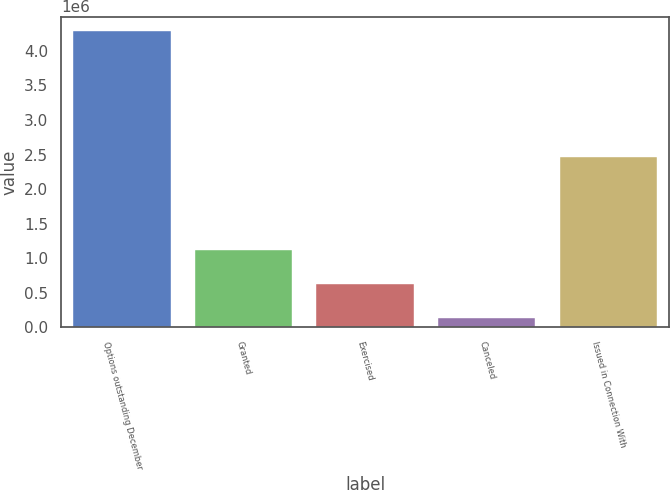Convert chart. <chart><loc_0><loc_0><loc_500><loc_500><bar_chart><fcel>Options outstanding December<fcel>Granted<fcel>Exercised<fcel>Canceled<fcel>Issued in Connection With<nl><fcel>4.28439e+06<fcel>1.11804e+06<fcel>626727<fcel>135414<fcel>2.46714e+06<nl></chart> 